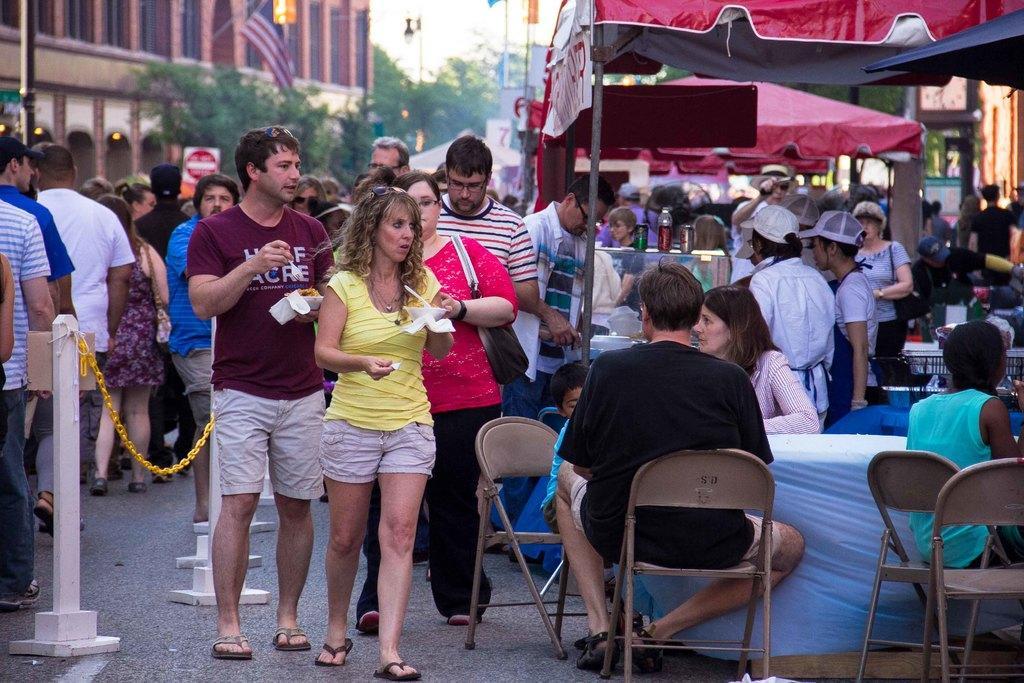How would you summarize this image in a sentence or two? There are some persons sitting in chairs in front of a table beside them there are some persons standing and holding some eatables in their hand and there are some group of people standing behind them. 